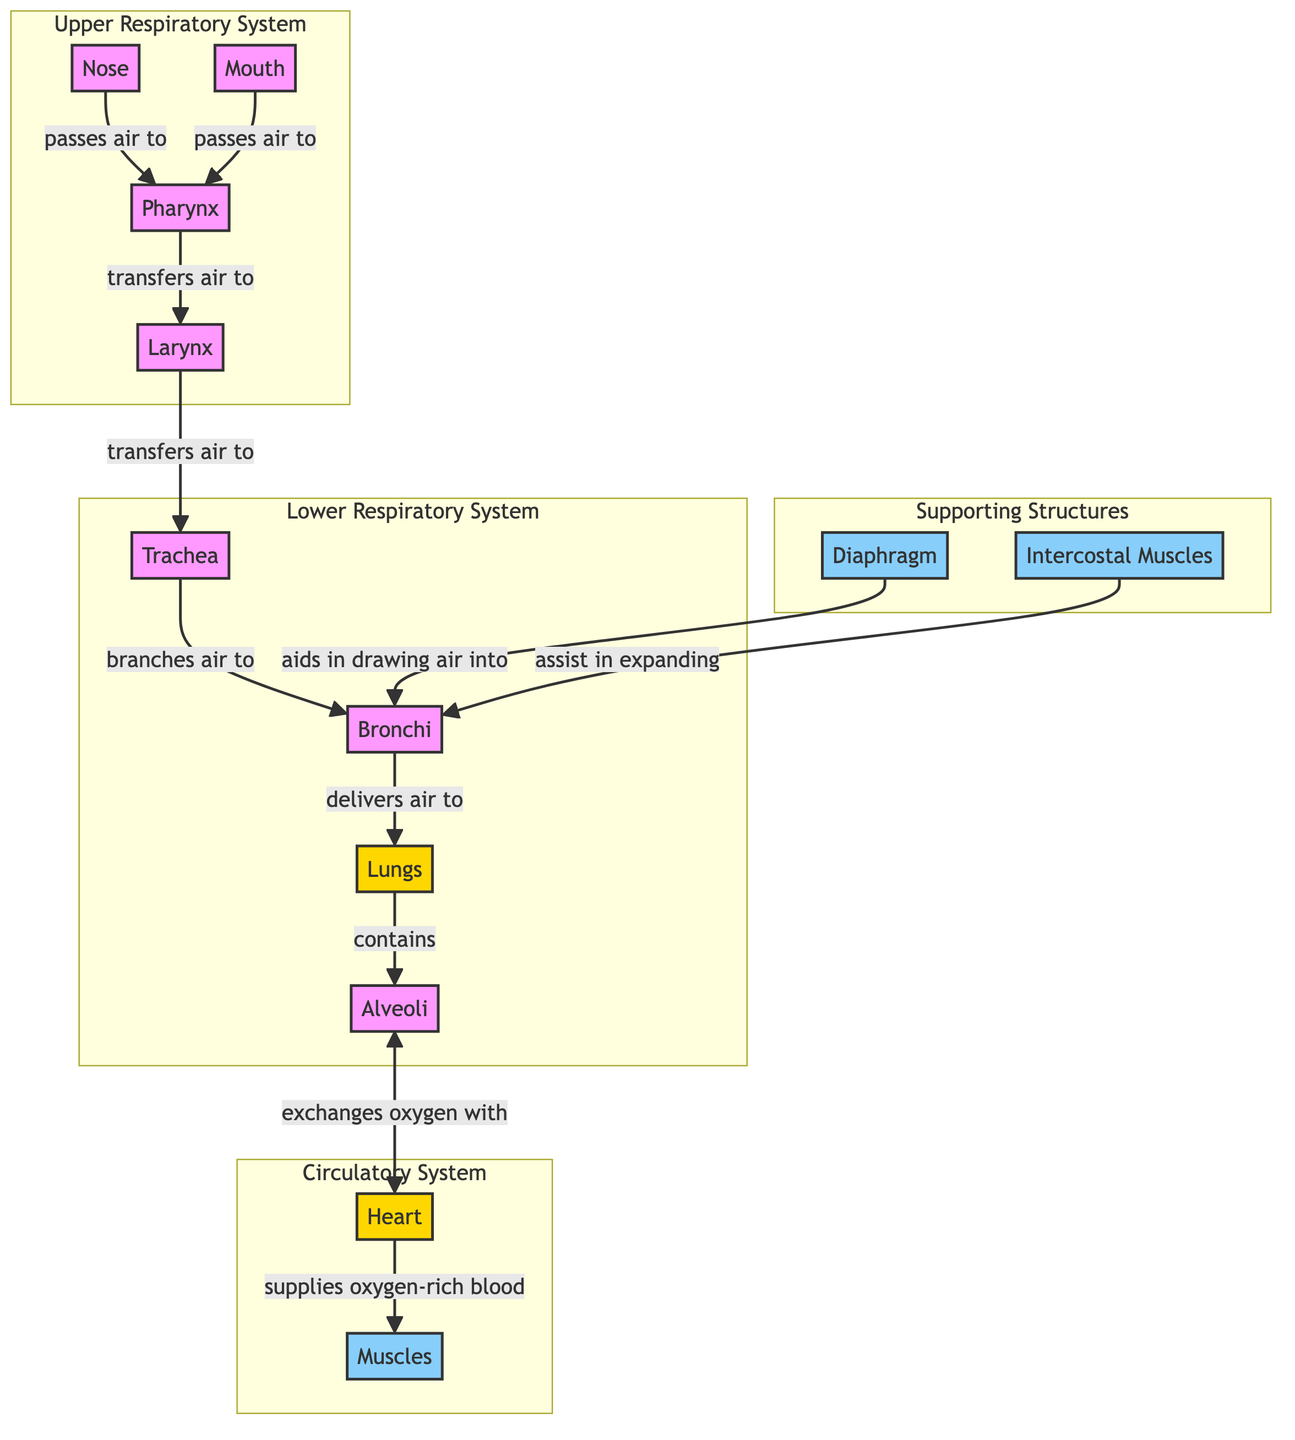What structure is responsible for transferring air from the pharynx to the trachea? The diagram shows that the pharynx transfers air to the larynx.
Answer: Larynx How many parts are in the Upper Respiratory System? The Upper Respiratory System contains four parts: nose, mouth, pharynx, and larynx.
Answer: 4 What are the muscles involved in the respiratory system? The diagram indicates that the diaphragm and intercostal muscles are involved in the respiratory process.
Answer: Diaphragm, Intercostal Muscles Which structure aids in drawing air into the trachea? According to the diagram, the diaphragm aids in drawing air into the trachea.
Answer: Diaphragm Which part of the respiratory system exchanges oxygen with the circulatory system? The diagram illustrates that the alveoli exchange oxygen with the heart in the circulatory system.
Answer: Alveoli What does the trachea branch into? The diagram shows that the trachea branches into the bronchi.
Answer: Bronchi How are the lungs connected to the bronchi? The diagram indicates that the bronchi delivers air to the lungs.
Answer: Delivers air What supplies oxygen-rich blood to the muscles? The heart supplies oxygen-rich blood to the muscles.
Answer: Heart What is the primary function of the intercostal muscles? The diagram states that intercostal muscles assist in expanding the bronchi during respiration.
Answer: Assist in expanding 